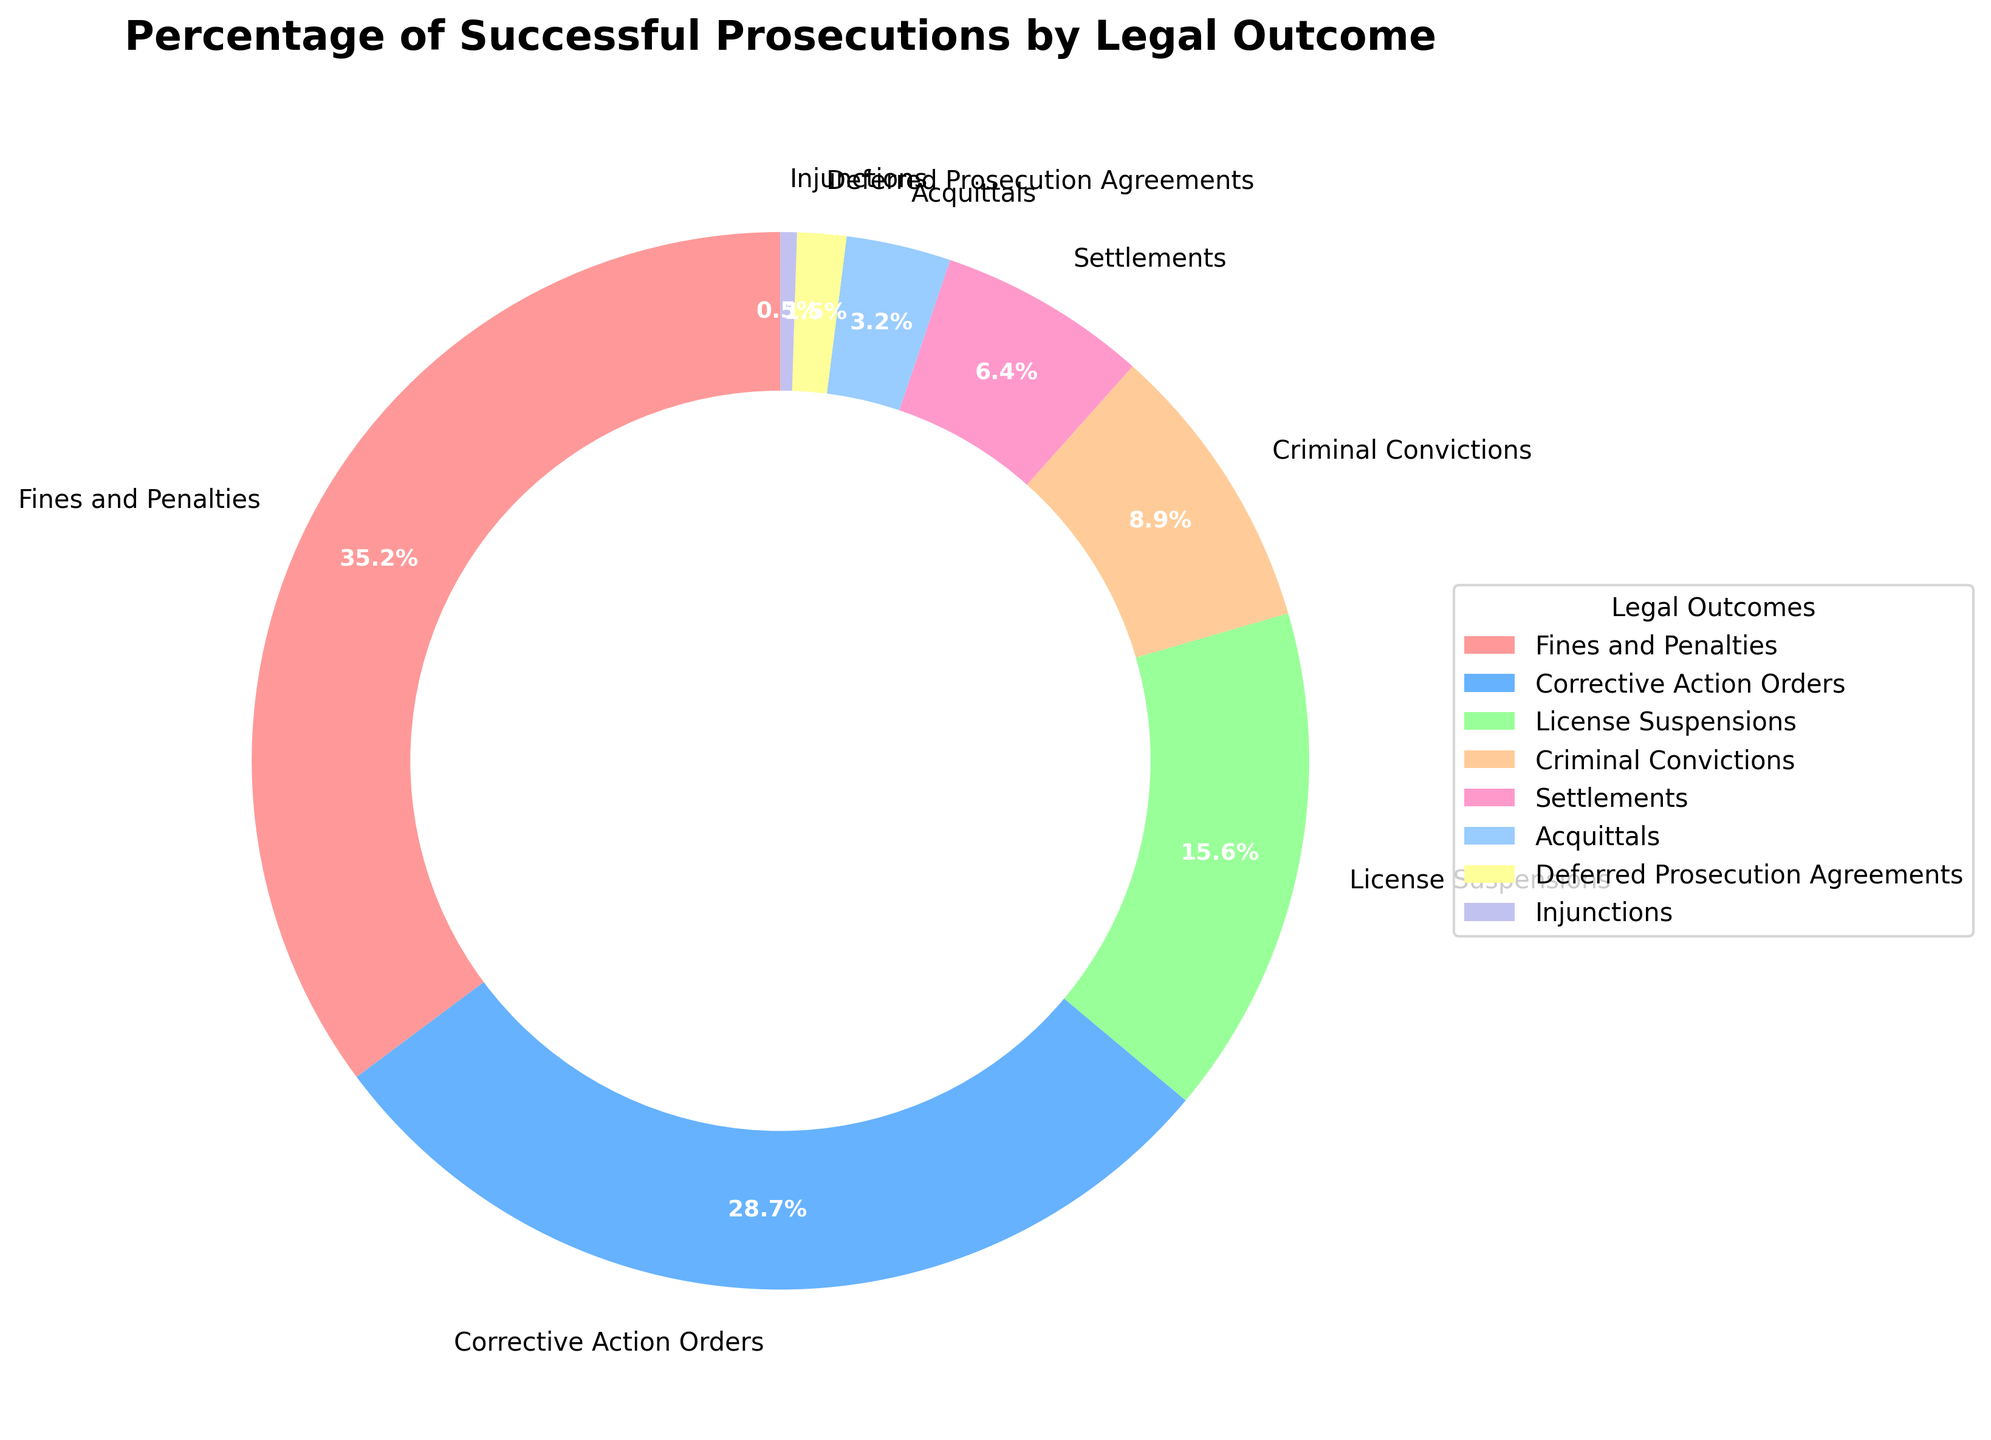What's the largest category by percentage in the pie chart? The largest category by percentage in the pie chart is the one with the highest value. From the data, "Fines and Penalties" has the highest value at 35.2%.
Answer: Fines and Penalties Which legal outcome has the lowest percentage? To find the lowest percentage, we look at the smallest value in the data. "Injunctions" has the smallest value at 0.5%.
Answer: Injunctions What's the combined percentage of "Criminal Convictions" and "Settlements"? Add the percentages of "Criminal Convictions" (8.9%) and "Settlements" (6.4%). The sum is 8.9 + 6.4 = 15.3%.
Answer: 15.3% How does the percentage of "License Suspensions" compare to "Corrective Action Orders"? Comparing the two percentages: "License Suspensions" is 15.6% and "Corrective Action Orders" is 28.7%. "Corrective Action Orders" has a higher percentage.
Answer: Corrective Action Orders What's the difference between the percentage of "Fines and Penalties" and "Deferred Prosecution Agreements"? Subtract the percentage of "Deferred Prosecution Agreements" (1.5%) from "Fines and Penalties" (35.2%). The result is 35.2 - 1.5 = 33.7%.
Answer: 33.7% Which legal outcome categories together make up over 50% of the pie chart? The total percentage needs to add up to over 50%. Starting from the largest: "Fines and Penalties" (35.2%) + "Corrective Action Orders" (28.7%) = 63.9%, which is over 50%. Hence, these two categories together make up over 50%.
Answer: Fines and Penalties and Corrective Action Orders What's the total percentage of categories with a percentage less than 5%? Add the percentages of "Acquittals" (3.2%), "Deferred Prosecution Agreements" (1.5%), and "Injunctions" (0.5%). The sum is 3.2 + 1.5 + 0.5 = 5.2%.
Answer: 5.2% Is the percentage of "Settlements" greater or less than "Acquittals"? Compare the percentages: "Settlements" is 6.4% and "Acquittals" is 3.2%. "Settlements" has a higher percentage.
Answer: Greater What color represents "Corrective Action Orders" in the pie chart? From the data, "Corrective Action Orders" is the second segment, which is represented by the second color in the custom colors array, which is a shade of blue.
Answer: Blue What's the percentage difference between the highest and the lowest category? Subtract the lowest percentage "Injunctions" (0.5%) from the highest "Fines and Penalties" (35.2%). The difference is 35.2 - 0.5 = 34.7%.
Answer: 34.7% 